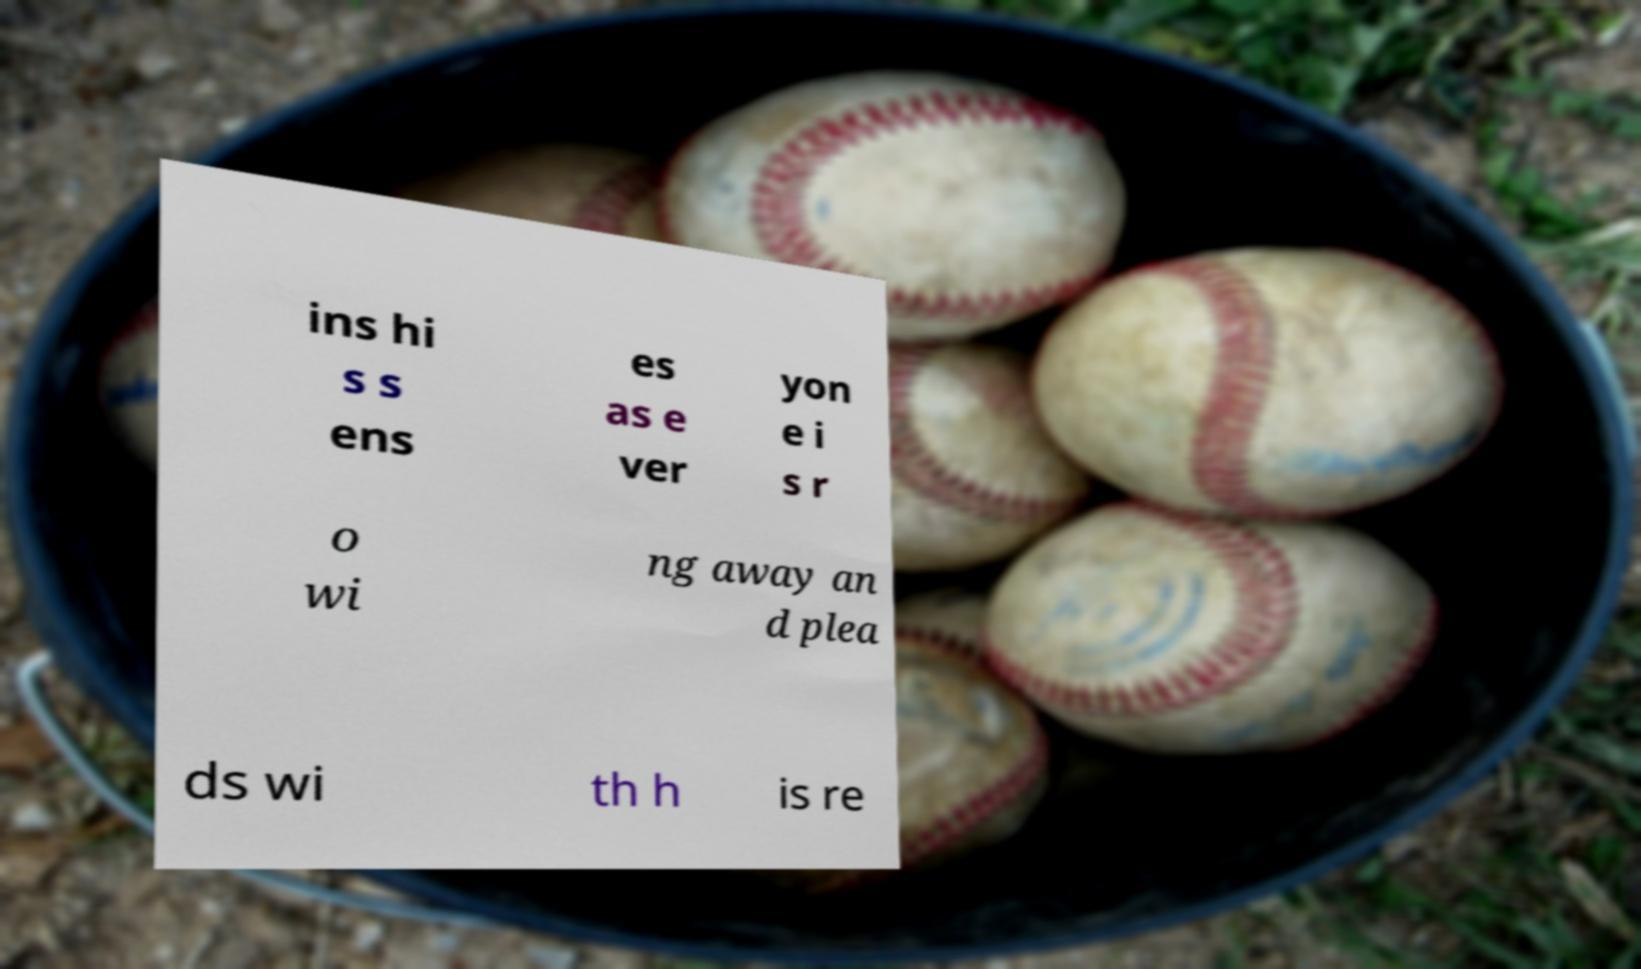Can you read and provide the text displayed in the image?This photo seems to have some interesting text. Can you extract and type it out for me? ins hi s s ens es as e ver yon e i s r o wi ng away an d plea ds wi th h is re 